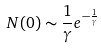<formula> <loc_0><loc_0><loc_500><loc_500>N ( 0 ) \sim \frac { 1 } { \gamma } e ^ { - \frac { 1 } { \gamma } }</formula> 